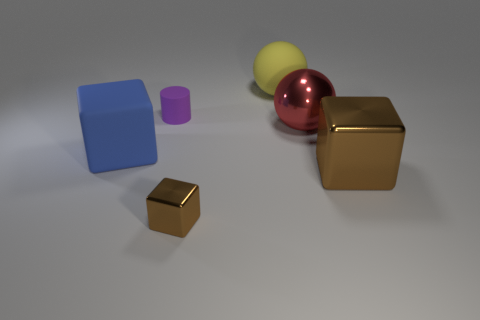How many yellow objects are small shiny blocks or tiny things?
Your response must be concise. 0. Are the tiny purple object and the large cube that is to the right of the big blue cube made of the same material?
Your response must be concise. No. There is another shiny thing that is the same shape as the small brown shiny thing; what size is it?
Provide a short and direct response. Large. What is the small purple cylinder made of?
Your response must be concise. Rubber. What is the material of the cube in front of the big cube that is in front of the cube to the left of the cylinder?
Provide a short and direct response. Metal. Do the object behind the tiny purple matte cylinder and the brown metallic cube that is to the left of the big red shiny ball have the same size?
Provide a short and direct response. No. What number of other objects are there of the same material as the tiny purple thing?
Provide a short and direct response. 2. How many shiny objects are cubes or small things?
Make the answer very short. 2. Are there fewer small brown rubber objects than large brown metal objects?
Give a very brief answer. Yes. There is a purple thing; does it have the same size as the brown object on the right side of the red ball?
Your answer should be compact. No. 